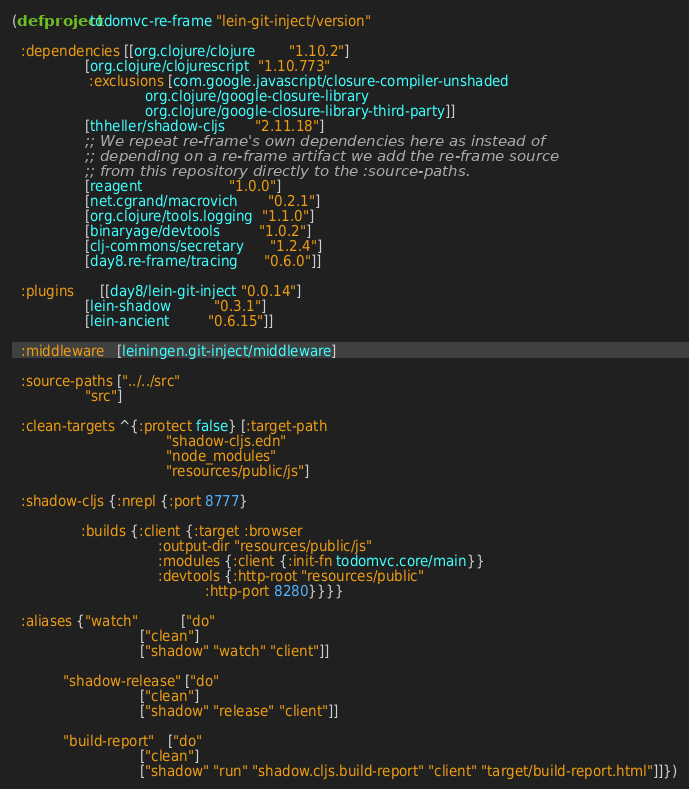Convert code to text. <code><loc_0><loc_0><loc_500><loc_500><_Clojure_>(defproject todomvc-re-frame "lein-git-inject/version"

  :dependencies [[org.clojure/clojure        "1.10.2"]
                 [org.clojure/clojurescript  "1.10.773"
                  :exclusions [com.google.javascript/closure-compiler-unshaded
                               org.clojure/google-closure-library
                               org.clojure/google-closure-library-third-party]]
                 [thheller/shadow-cljs       "2.11.18"]
                 ;; We repeat re-frame's own dependencies here as instead of
                 ;; depending on a re-frame artifact we add the re-frame source
                 ;; from this repository directly to the :source-paths.
                 [reagent                    "1.0.0"]
                 [net.cgrand/macrovich       "0.2.1"]
                 [org.clojure/tools.logging  "1.1.0"]
                 [binaryage/devtools         "1.0.2"]
                 [clj-commons/secretary      "1.2.4"]
                 [day8.re-frame/tracing      "0.6.0"]]

  :plugins      [[day8/lein-git-inject "0.0.14"]
                 [lein-shadow          "0.3.1"]
                 [lein-ancient         "0.6.15"]]

  :middleware   [leiningen.git-inject/middleware]

  :source-paths ["../../src"
                 "src"]

  :clean-targets ^{:protect false} [:target-path
                                    "shadow-cljs.edn"
                                    "node_modules"
                                    "resources/public/js"]

  :shadow-cljs {:nrepl {:port 8777}

                :builds {:client {:target :browser
                                  :output-dir "resources/public/js"
                                  :modules {:client {:init-fn todomvc.core/main}}
                                  :devtools {:http-root "resources/public"
                                             :http-port 8280}}}}

  :aliases {"watch"          ["do"
                              ["clean"]
                              ["shadow" "watch" "client"]]

            "shadow-release" ["do"
                              ["clean"]
                              ["shadow" "release" "client"]]

            "build-report"   ["do"
                              ["clean"]
                              ["shadow" "run" "shadow.cljs.build-report" "client" "target/build-report.html"]]})
</code> 